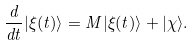Convert formula to latex. <formula><loc_0><loc_0><loc_500><loc_500>\frac { d } { d t } | \xi ( t ) \rangle = M | \xi ( t ) \rangle + | \chi \rangle .</formula> 